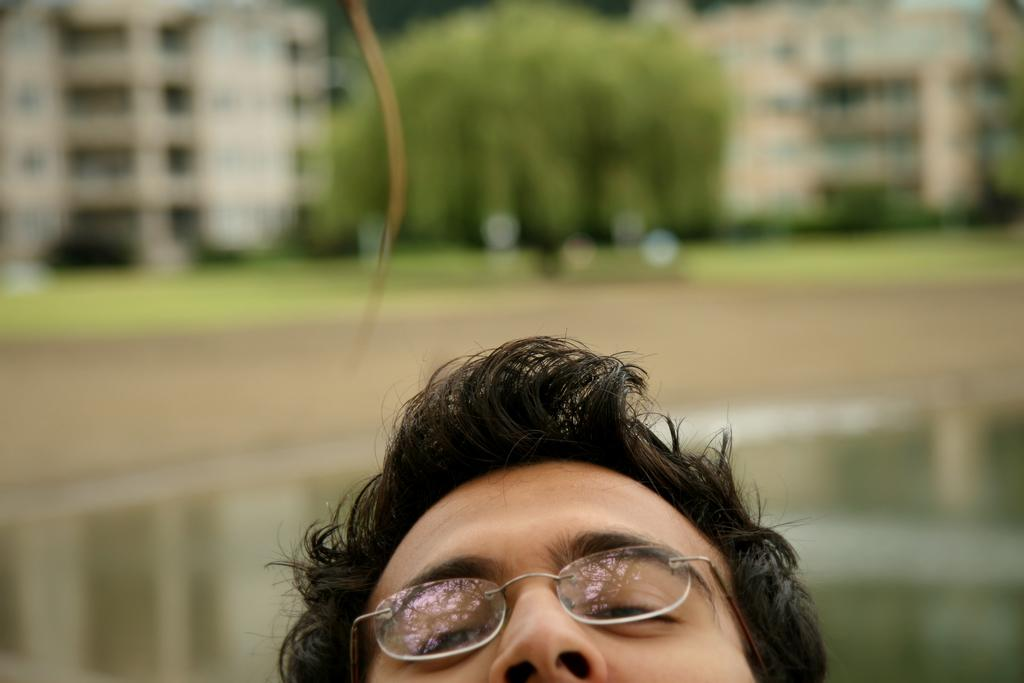What is the person in the image wearing? The person in the image is wearing spectacles. What can be seen in the background of the image? The background of the image includes the ground, trees, and buildings. What type of zebra can be seen cooking in the image? There is no zebra or cooking activity present in the image. 